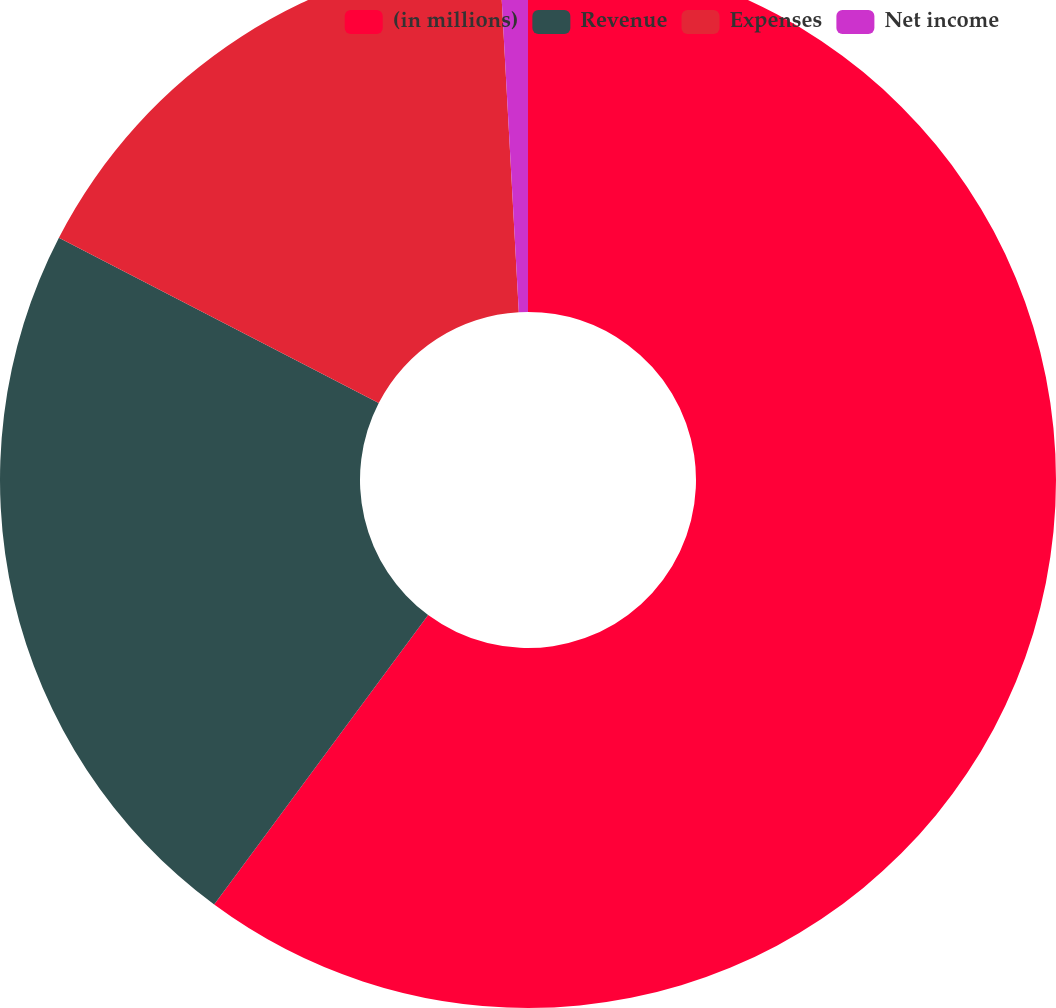Convert chart to OTSL. <chart><loc_0><loc_0><loc_500><loc_500><pie_chart><fcel>(in millions)<fcel>Revenue<fcel>Expenses<fcel>Net income<nl><fcel>60.13%<fcel>22.46%<fcel>16.54%<fcel>0.87%<nl></chart> 